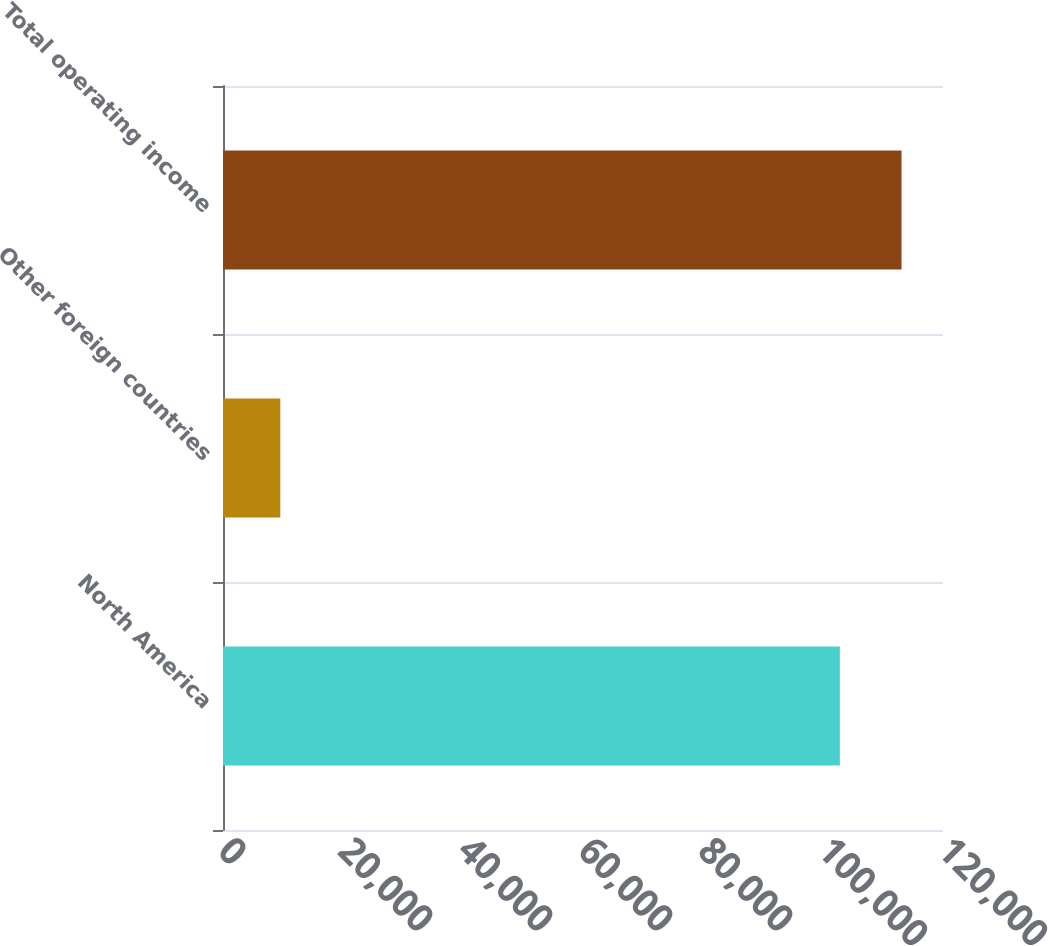Convert chart to OTSL. <chart><loc_0><loc_0><loc_500><loc_500><bar_chart><fcel>North America<fcel>Other foreign countries<fcel>Total operating income<nl><fcel>102806<fcel>9549<fcel>113087<nl></chart> 